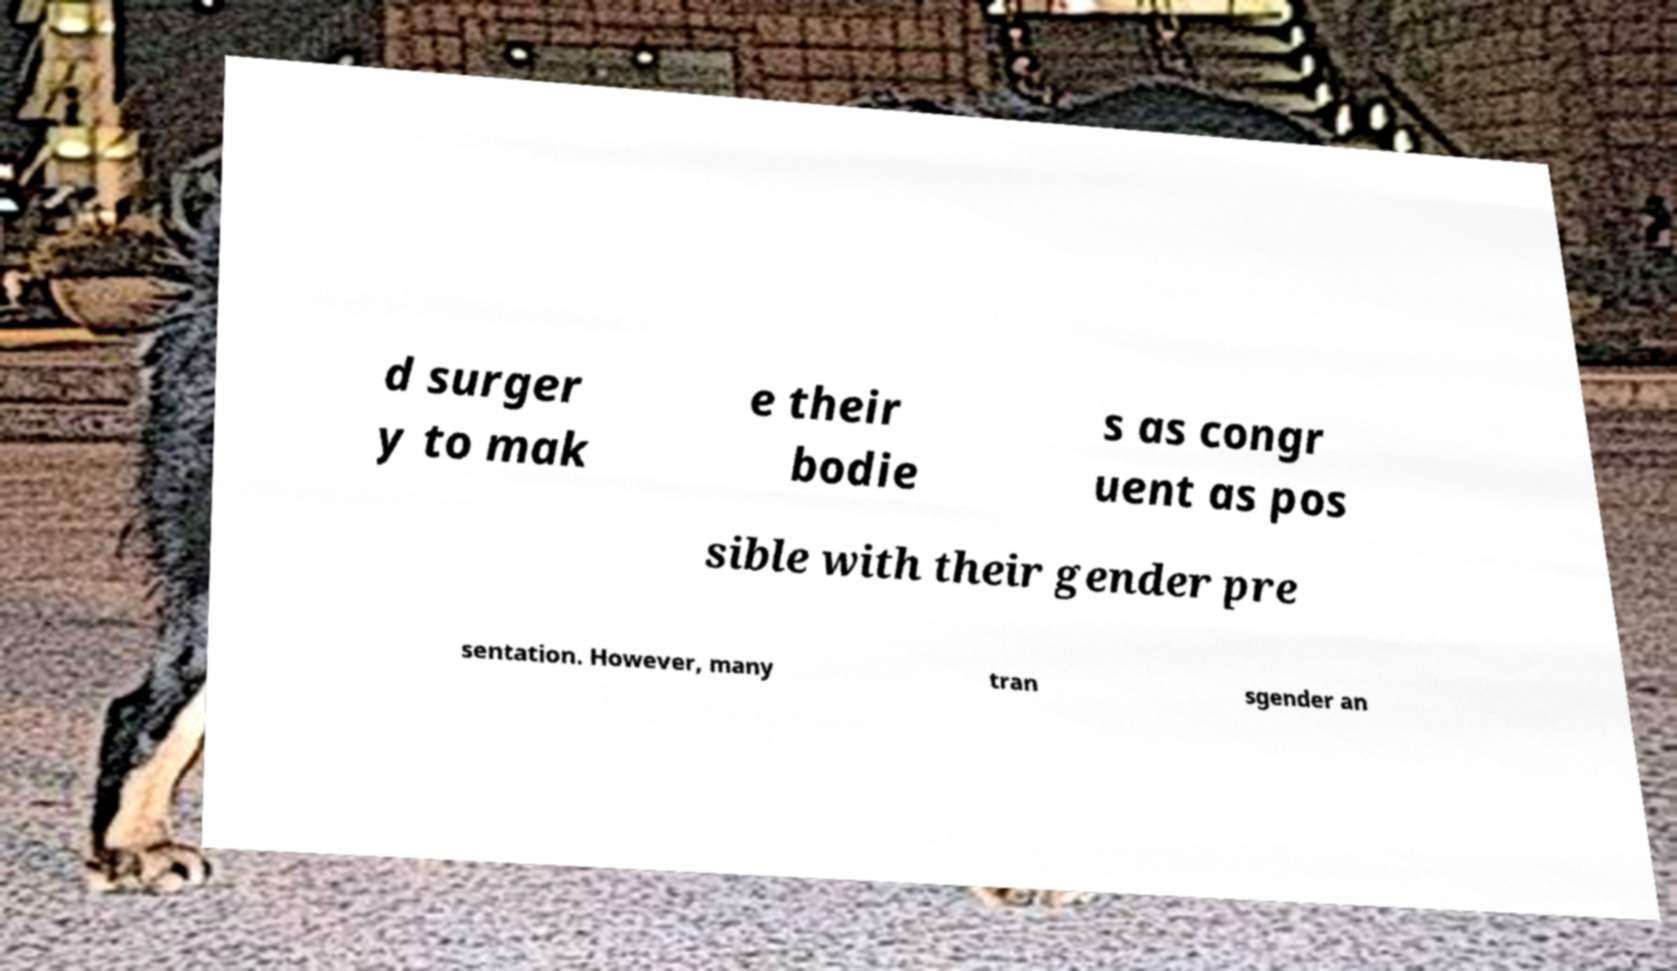There's text embedded in this image that I need extracted. Can you transcribe it verbatim? d surger y to mak e their bodie s as congr uent as pos sible with their gender pre sentation. However, many tran sgender an 